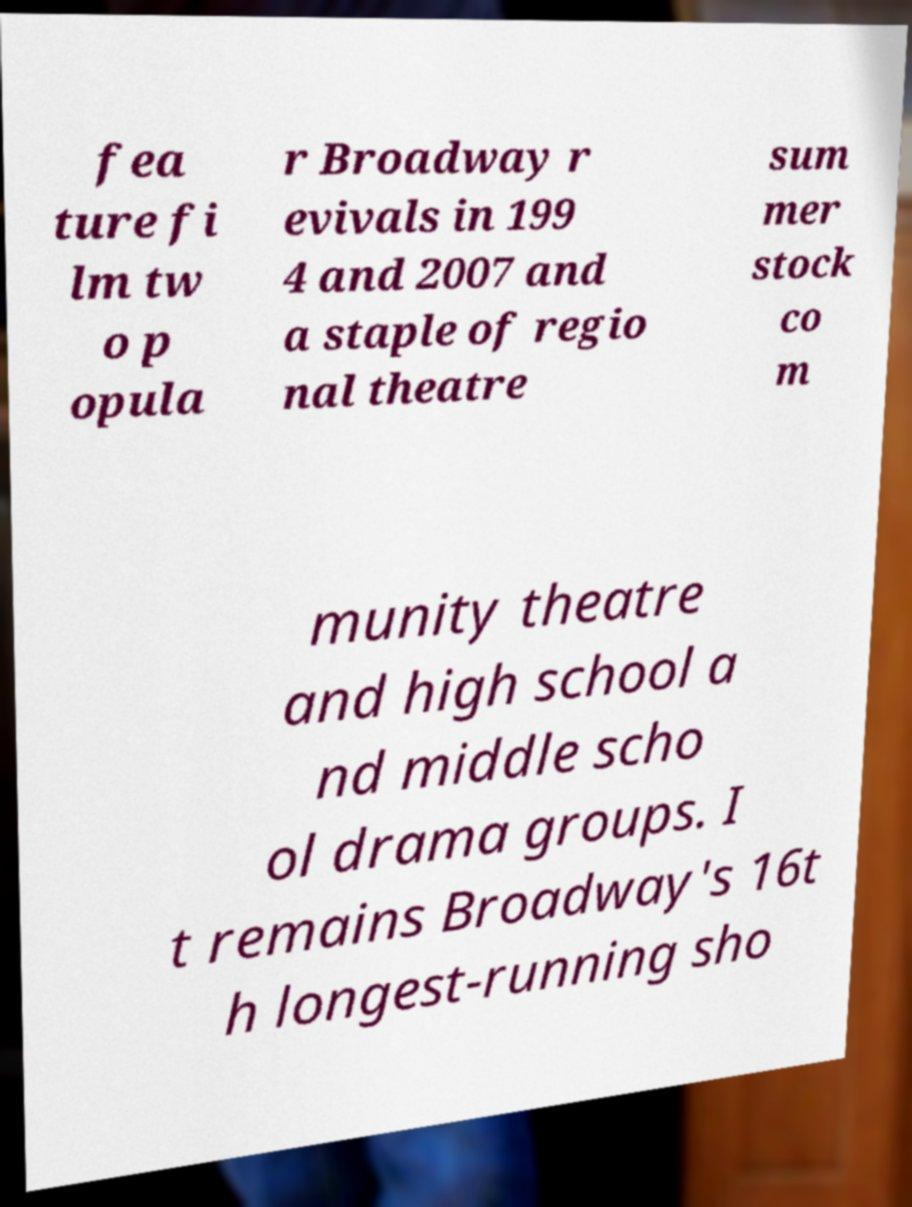Can you read and provide the text displayed in the image?This photo seems to have some interesting text. Can you extract and type it out for me? fea ture fi lm tw o p opula r Broadway r evivals in 199 4 and 2007 and a staple of regio nal theatre sum mer stock co m munity theatre and high school a nd middle scho ol drama groups. I t remains Broadway's 16t h longest-running sho 